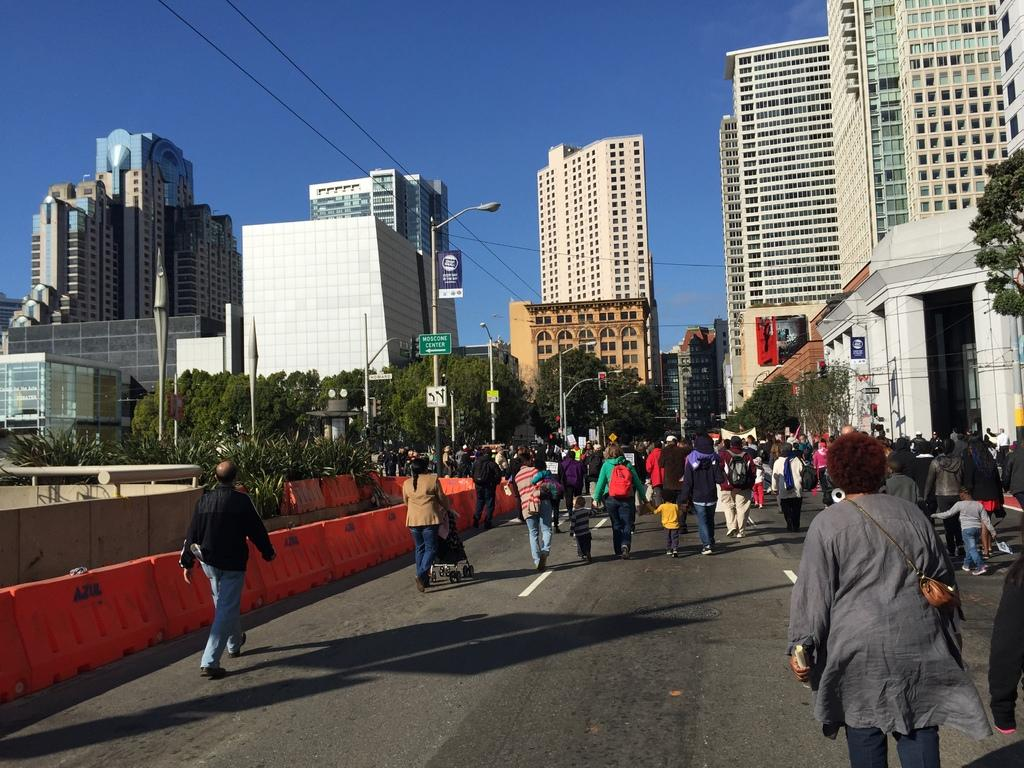What are the people in the image doing? There is a group of people standing on the road in the image. What objects can be seen in the image that are related to electricity or communication? There are poles, lights, boards, and cables in the image. What type of structures are visible in the image? There are buildings in the image. What type of vegetation can be seen in the image? There are trees in the image. What is visible in the background of the image? The sky is visible in the background of the image. What type of yam is being served to the visitor in the image? There is no yam or visitor present in the image. 